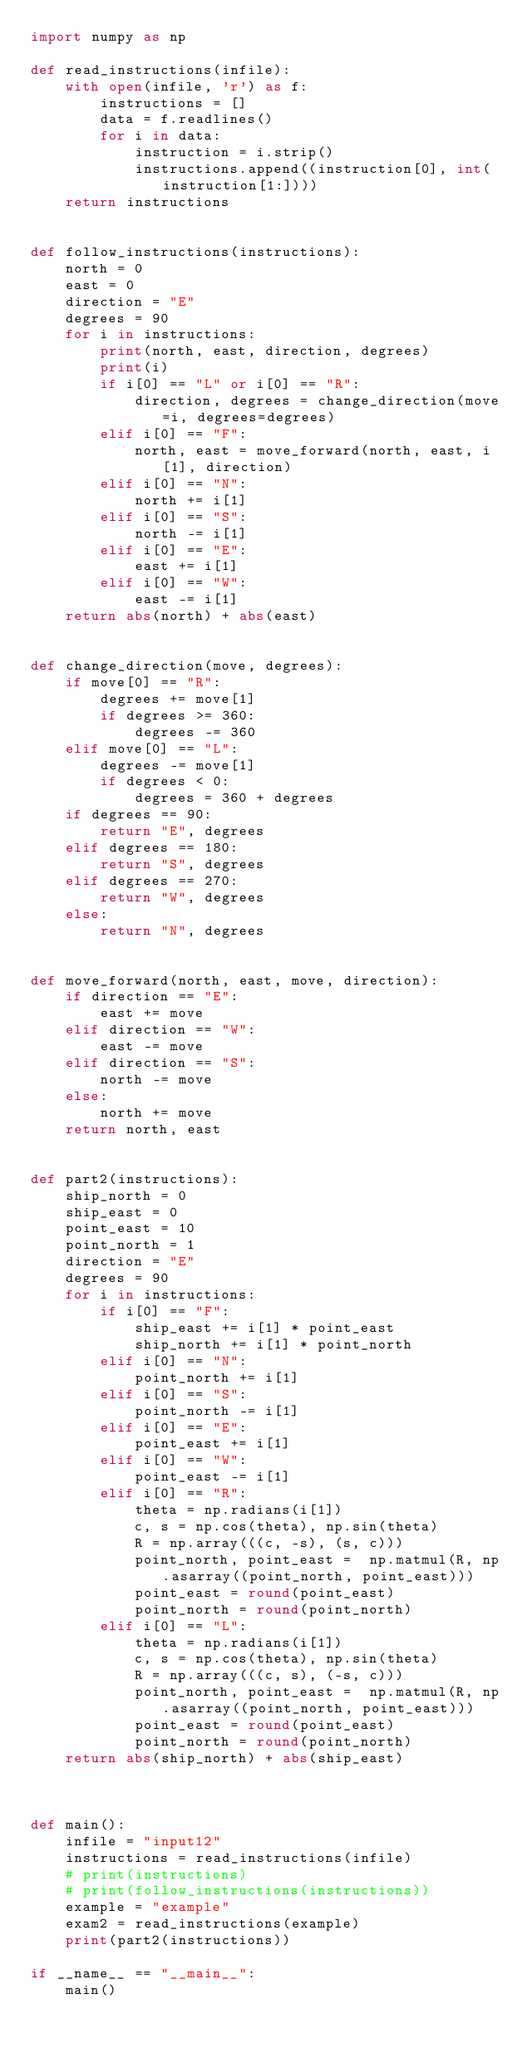Convert code to text. <code><loc_0><loc_0><loc_500><loc_500><_Python_>import numpy as np

def read_instructions(infile):
    with open(infile, 'r') as f:
        instructions = []
        data = f.readlines()
        for i in data:
            instruction = i.strip()
            instructions.append((instruction[0], int(instruction[1:])))
    return instructions


def follow_instructions(instructions):
    north = 0
    east = 0
    direction = "E"
    degrees = 90
    for i in instructions:
        print(north, east, direction, degrees)
        print(i)
        if i[0] == "L" or i[0] == "R":
            direction, degrees = change_direction(move=i, degrees=degrees)
        elif i[0] == "F":
            north, east = move_forward(north, east, i[1], direction)
        elif i[0] == "N":
            north += i[1]
        elif i[0] == "S":
            north -= i[1]
        elif i[0] == "E":
            east += i[1]
        elif i[0] == "W":
            east -= i[1]
    return abs(north) + abs(east)


def change_direction(move, degrees):
    if move[0] == "R":
        degrees += move[1]
        if degrees >= 360:
            degrees -= 360
    elif move[0] == "L":
        degrees -= move[1]
        if degrees < 0:
            degrees = 360 + degrees
    if degrees == 90:
        return "E", degrees
    elif degrees == 180:
        return "S", degrees
    elif degrees == 270:
        return "W", degrees
    else:
        return "N", degrees


def move_forward(north, east, move, direction):
    if direction == "E":
        east += move
    elif direction == "W":
        east -= move
    elif direction == "S":
        north -= move
    else:
        north += move
    return north, east


def part2(instructions):
    ship_north = 0
    ship_east = 0
    point_east = 10
    point_north = 1
    direction = "E"
    degrees = 90
    for i in instructions:
        if i[0] == "F":
            ship_east += i[1] * point_east
            ship_north += i[1] * point_north
        elif i[0] == "N":
            point_north += i[1]
        elif i[0] == "S":
            point_north -= i[1]
        elif i[0] == "E":
            point_east += i[1]
        elif i[0] == "W":
            point_east -= i[1]
        elif i[0] == "R":
            theta = np.radians(i[1])
            c, s = np.cos(theta), np.sin(theta)
            R = np.array(((c, -s), (s, c)))
            point_north, point_east =  np.matmul(R, np.asarray((point_north, point_east)))
            point_east = round(point_east)
            point_north = round(point_north)
        elif i[0] == "L":
            theta = np.radians(i[1])
            c, s = np.cos(theta), np.sin(theta)
            R = np.array(((c, s), (-s, c)))
            point_north, point_east =  np.matmul(R, np.asarray((point_north, point_east)))
            point_east = round(point_east)
            point_north = round(point_north)
    return abs(ship_north) + abs(ship_east)



def main():
    infile = "input12"
    instructions = read_instructions(infile)
    # print(instructions)
    # print(follow_instructions(instructions))
    example = "example"
    exam2 = read_instructions(example)
    print(part2(instructions))

if __name__ == "__main__":
    main()
</code> 